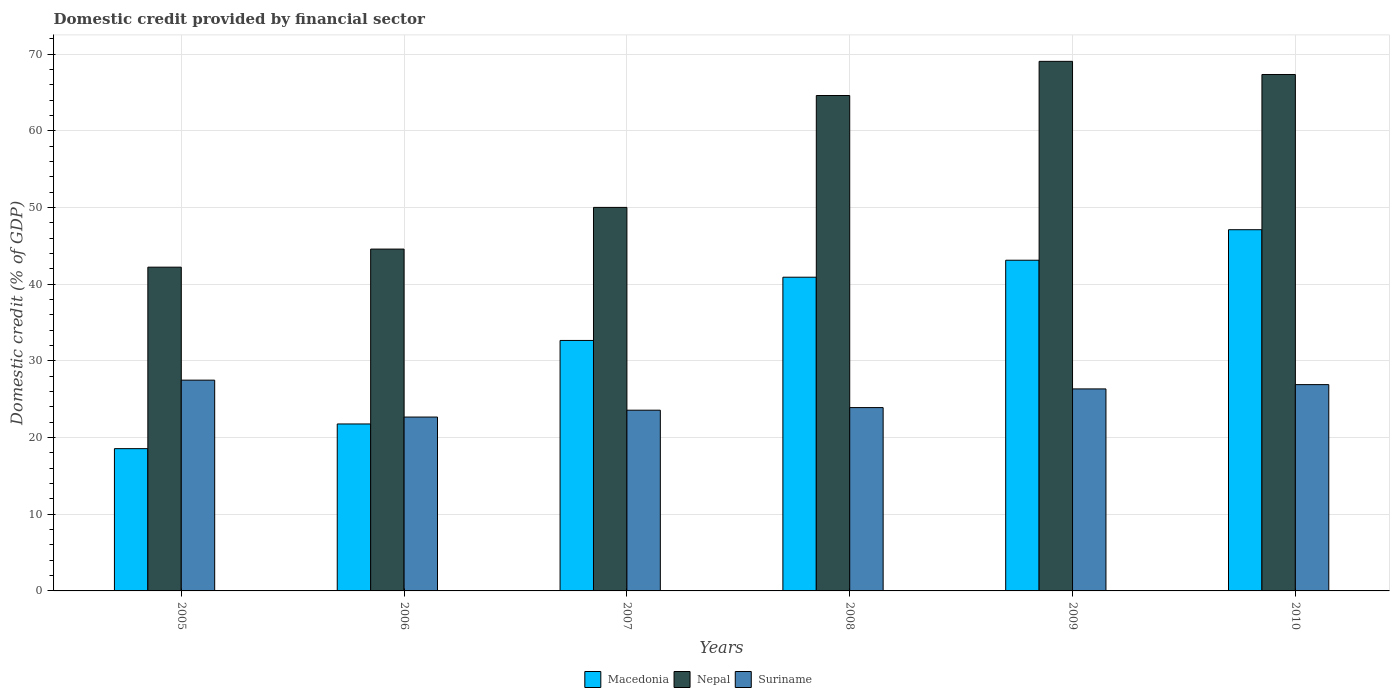How many groups of bars are there?
Offer a terse response. 6. How many bars are there on the 2nd tick from the left?
Make the answer very short. 3. What is the label of the 5th group of bars from the left?
Provide a short and direct response. 2009. In how many cases, is the number of bars for a given year not equal to the number of legend labels?
Give a very brief answer. 0. What is the domestic credit in Nepal in 2006?
Your answer should be very brief. 44.58. Across all years, what is the maximum domestic credit in Suriname?
Ensure brevity in your answer.  27.49. Across all years, what is the minimum domestic credit in Suriname?
Offer a terse response. 22.68. What is the total domestic credit in Macedonia in the graph?
Give a very brief answer. 204.15. What is the difference between the domestic credit in Nepal in 2007 and that in 2010?
Provide a short and direct response. -17.33. What is the difference between the domestic credit in Nepal in 2005 and the domestic credit in Suriname in 2009?
Offer a terse response. 15.88. What is the average domestic credit in Nepal per year?
Ensure brevity in your answer.  56.31. In the year 2009, what is the difference between the domestic credit in Nepal and domestic credit in Suriname?
Give a very brief answer. 42.72. In how many years, is the domestic credit in Suriname greater than 64 %?
Keep it short and to the point. 0. What is the ratio of the domestic credit in Suriname in 2005 to that in 2006?
Offer a terse response. 1.21. Is the domestic credit in Nepal in 2007 less than that in 2009?
Your answer should be very brief. Yes. Is the difference between the domestic credit in Nepal in 2006 and 2007 greater than the difference between the domestic credit in Suriname in 2006 and 2007?
Give a very brief answer. No. What is the difference between the highest and the second highest domestic credit in Macedonia?
Ensure brevity in your answer.  3.98. What is the difference between the highest and the lowest domestic credit in Macedonia?
Offer a terse response. 28.55. In how many years, is the domestic credit in Nepal greater than the average domestic credit in Nepal taken over all years?
Provide a short and direct response. 3. What does the 3rd bar from the left in 2009 represents?
Your response must be concise. Suriname. What does the 3rd bar from the right in 2008 represents?
Give a very brief answer. Macedonia. Is it the case that in every year, the sum of the domestic credit in Nepal and domestic credit in Macedonia is greater than the domestic credit in Suriname?
Your answer should be very brief. Yes. How many bars are there?
Offer a very short reply. 18. How many years are there in the graph?
Ensure brevity in your answer.  6. Are the values on the major ticks of Y-axis written in scientific E-notation?
Your answer should be compact. No. Does the graph contain grids?
Offer a terse response. Yes. Where does the legend appear in the graph?
Give a very brief answer. Bottom center. How many legend labels are there?
Provide a short and direct response. 3. What is the title of the graph?
Keep it short and to the point. Domestic credit provided by financial sector. Does "Venezuela" appear as one of the legend labels in the graph?
Ensure brevity in your answer.  No. What is the label or title of the X-axis?
Make the answer very short. Years. What is the label or title of the Y-axis?
Make the answer very short. Domestic credit (% of GDP). What is the Domestic credit (% of GDP) in Macedonia in 2005?
Your answer should be compact. 18.55. What is the Domestic credit (% of GDP) in Nepal in 2005?
Your answer should be very brief. 42.22. What is the Domestic credit (% of GDP) of Suriname in 2005?
Your response must be concise. 27.49. What is the Domestic credit (% of GDP) of Macedonia in 2006?
Your answer should be very brief. 21.78. What is the Domestic credit (% of GDP) in Nepal in 2006?
Offer a terse response. 44.58. What is the Domestic credit (% of GDP) in Suriname in 2006?
Offer a terse response. 22.68. What is the Domestic credit (% of GDP) of Macedonia in 2007?
Provide a short and direct response. 32.67. What is the Domestic credit (% of GDP) of Nepal in 2007?
Provide a short and direct response. 50.02. What is the Domestic credit (% of GDP) in Suriname in 2007?
Keep it short and to the point. 23.57. What is the Domestic credit (% of GDP) of Macedonia in 2008?
Your answer should be very brief. 40.91. What is the Domestic credit (% of GDP) of Nepal in 2008?
Provide a succinct answer. 64.61. What is the Domestic credit (% of GDP) of Suriname in 2008?
Your answer should be compact. 23.91. What is the Domestic credit (% of GDP) in Macedonia in 2009?
Your answer should be very brief. 43.13. What is the Domestic credit (% of GDP) in Nepal in 2009?
Ensure brevity in your answer.  69.07. What is the Domestic credit (% of GDP) of Suriname in 2009?
Provide a short and direct response. 26.35. What is the Domestic credit (% of GDP) of Macedonia in 2010?
Your response must be concise. 47.11. What is the Domestic credit (% of GDP) of Nepal in 2010?
Provide a succinct answer. 67.35. What is the Domestic credit (% of GDP) in Suriname in 2010?
Offer a terse response. 26.91. Across all years, what is the maximum Domestic credit (% of GDP) of Macedonia?
Make the answer very short. 47.11. Across all years, what is the maximum Domestic credit (% of GDP) of Nepal?
Make the answer very short. 69.07. Across all years, what is the maximum Domestic credit (% of GDP) of Suriname?
Offer a terse response. 27.49. Across all years, what is the minimum Domestic credit (% of GDP) in Macedonia?
Make the answer very short. 18.55. Across all years, what is the minimum Domestic credit (% of GDP) in Nepal?
Provide a succinct answer. 42.22. Across all years, what is the minimum Domestic credit (% of GDP) of Suriname?
Give a very brief answer. 22.68. What is the total Domestic credit (% of GDP) in Macedonia in the graph?
Your answer should be compact. 204.15. What is the total Domestic credit (% of GDP) in Nepal in the graph?
Your response must be concise. 337.86. What is the total Domestic credit (% of GDP) of Suriname in the graph?
Provide a short and direct response. 150.9. What is the difference between the Domestic credit (% of GDP) in Macedonia in 2005 and that in 2006?
Provide a short and direct response. -3.22. What is the difference between the Domestic credit (% of GDP) of Nepal in 2005 and that in 2006?
Your response must be concise. -2.36. What is the difference between the Domestic credit (% of GDP) in Suriname in 2005 and that in 2006?
Offer a terse response. 4.81. What is the difference between the Domestic credit (% of GDP) in Macedonia in 2005 and that in 2007?
Ensure brevity in your answer.  -14.11. What is the difference between the Domestic credit (% of GDP) in Nepal in 2005 and that in 2007?
Your answer should be compact. -7.8. What is the difference between the Domestic credit (% of GDP) of Suriname in 2005 and that in 2007?
Provide a short and direct response. 3.92. What is the difference between the Domestic credit (% of GDP) in Macedonia in 2005 and that in 2008?
Offer a very short reply. -22.36. What is the difference between the Domestic credit (% of GDP) of Nepal in 2005 and that in 2008?
Make the answer very short. -22.39. What is the difference between the Domestic credit (% of GDP) in Suriname in 2005 and that in 2008?
Offer a terse response. 3.58. What is the difference between the Domestic credit (% of GDP) in Macedonia in 2005 and that in 2009?
Provide a short and direct response. -24.57. What is the difference between the Domestic credit (% of GDP) of Nepal in 2005 and that in 2009?
Provide a succinct answer. -26.84. What is the difference between the Domestic credit (% of GDP) of Macedonia in 2005 and that in 2010?
Your response must be concise. -28.55. What is the difference between the Domestic credit (% of GDP) of Nepal in 2005 and that in 2010?
Your answer should be very brief. -25.13. What is the difference between the Domestic credit (% of GDP) in Suriname in 2005 and that in 2010?
Provide a succinct answer. 0.58. What is the difference between the Domestic credit (% of GDP) of Macedonia in 2006 and that in 2007?
Your answer should be compact. -10.89. What is the difference between the Domestic credit (% of GDP) of Nepal in 2006 and that in 2007?
Your answer should be very brief. -5.44. What is the difference between the Domestic credit (% of GDP) of Suriname in 2006 and that in 2007?
Make the answer very short. -0.89. What is the difference between the Domestic credit (% of GDP) in Macedonia in 2006 and that in 2008?
Ensure brevity in your answer.  -19.14. What is the difference between the Domestic credit (% of GDP) in Nepal in 2006 and that in 2008?
Your response must be concise. -20.03. What is the difference between the Domestic credit (% of GDP) of Suriname in 2006 and that in 2008?
Your response must be concise. -1.24. What is the difference between the Domestic credit (% of GDP) in Macedonia in 2006 and that in 2009?
Make the answer very short. -21.35. What is the difference between the Domestic credit (% of GDP) of Nepal in 2006 and that in 2009?
Keep it short and to the point. -24.48. What is the difference between the Domestic credit (% of GDP) of Suriname in 2006 and that in 2009?
Give a very brief answer. -3.67. What is the difference between the Domestic credit (% of GDP) of Macedonia in 2006 and that in 2010?
Provide a succinct answer. -25.33. What is the difference between the Domestic credit (% of GDP) of Nepal in 2006 and that in 2010?
Provide a short and direct response. -22.77. What is the difference between the Domestic credit (% of GDP) in Suriname in 2006 and that in 2010?
Provide a succinct answer. -4.23. What is the difference between the Domestic credit (% of GDP) of Macedonia in 2007 and that in 2008?
Provide a short and direct response. -8.25. What is the difference between the Domestic credit (% of GDP) in Nepal in 2007 and that in 2008?
Give a very brief answer. -14.59. What is the difference between the Domestic credit (% of GDP) in Suriname in 2007 and that in 2008?
Provide a short and direct response. -0.34. What is the difference between the Domestic credit (% of GDP) of Macedonia in 2007 and that in 2009?
Keep it short and to the point. -10.46. What is the difference between the Domestic credit (% of GDP) of Nepal in 2007 and that in 2009?
Offer a terse response. -19.05. What is the difference between the Domestic credit (% of GDP) of Suriname in 2007 and that in 2009?
Your answer should be very brief. -2.78. What is the difference between the Domestic credit (% of GDP) in Macedonia in 2007 and that in 2010?
Offer a terse response. -14.44. What is the difference between the Domestic credit (% of GDP) in Nepal in 2007 and that in 2010?
Give a very brief answer. -17.33. What is the difference between the Domestic credit (% of GDP) in Suriname in 2007 and that in 2010?
Offer a very short reply. -3.33. What is the difference between the Domestic credit (% of GDP) in Macedonia in 2008 and that in 2009?
Your answer should be compact. -2.22. What is the difference between the Domestic credit (% of GDP) of Nepal in 2008 and that in 2009?
Your answer should be very brief. -4.46. What is the difference between the Domestic credit (% of GDP) in Suriname in 2008 and that in 2009?
Provide a short and direct response. -2.44. What is the difference between the Domestic credit (% of GDP) in Macedonia in 2008 and that in 2010?
Ensure brevity in your answer.  -6.2. What is the difference between the Domestic credit (% of GDP) in Nepal in 2008 and that in 2010?
Ensure brevity in your answer.  -2.74. What is the difference between the Domestic credit (% of GDP) of Suriname in 2008 and that in 2010?
Ensure brevity in your answer.  -2.99. What is the difference between the Domestic credit (% of GDP) in Macedonia in 2009 and that in 2010?
Your answer should be very brief. -3.98. What is the difference between the Domestic credit (% of GDP) in Nepal in 2009 and that in 2010?
Your answer should be compact. 1.71. What is the difference between the Domestic credit (% of GDP) in Suriname in 2009 and that in 2010?
Offer a terse response. -0.56. What is the difference between the Domestic credit (% of GDP) in Macedonia in 2005 and the Domestic credit (% of GDP) in Nepal in 2006?
Make the answer very short. -26.03. What is the difference between the Domestic credit (% of GDP) in Macedonia in 2005 and the Domestic credit (% of GDP) in Suriname in 2006?
Provide a short and direct response. -4.12. What is the difference between the Domestic credit (% of GDP) of Nepal in 2005 and the Domestic credit (% of GDP) of Suriname in 2006?
Provide a succinct answer. 19.55. What is the difference between the Domestic credit (% of GDP) in Macedonia in 2005 and the Domestic credit (% of GDP) in Nepal in 2007?
Keep it short and to the point. -31.47. What is the difference between the Domestic credit (% of GDP) of Macedonia in 2005 and the Domestic credit (% of GDP) of Suriname in 2007?
Offer a very short reply. -5.02. What is the difference between the Domestic credit (% of GDP) in Nepal in 2005 and the Domestic credit (% of GDP) in Suriname in 2007?
Ensure brevity in your answer.  18.65. What is the difference between the Domestic credit (% of GDP) in Macedonia in 2005 and the Domestic credit (% of GDP) in Nepal in 2008?
Make the answer very short. -46.06. What is the difference between the Domestic credit (% of GDP) in Macedonia in 2005 and the Domestic credit (% of GDP) in Suriname in 2008?
Your answer should be very brief. -5.36. What is the difference between the Domestic credit (% of GDP) in Nepal in 2005 and the Domestic credit (% of GDP) in Suriname in 2008?
Keep it short and to the point. 18.31. What is the difference between the Domestic credit (% of GDP) in Macedonia in 2005 and the Domestic credit (% of GDP) in Nepal in 2009?
Your answer should be very brief. -50.51. What is the difference between the Domestic credit (% of GDP) of Macedonia in 2005 and the Domestic credit (% of GDP) of Suriname in 2009?
Provide a short and direct response. -7.79. What is the difference between the Domestic credit (% of GDP) of Nepal in 2005 and the Domestic credit (% of GDP) of Suriname in 2009?
Your response must be concise. 15.88. What is the difference between the Domestic credit (% of GDP) of Macedonia in 2005 and the Domestic credit (% of GDP) of Nepal in 2010?
Your response must be concise. -48.8. What is the difference between the Domestic credit (% of GDP) in Macedonia in 2005 and the Domestic credit (% of GDP) in Suriname in 2010?
Make the answer very short. -8.35. What is the difference between the Domestic credit (% of GDP) in Nepal in 2005 and the Domestic credit (% of GDP) in Suriname in 2010?
Your answer should be very brief. 15.32. What is the difference between the Domestic credit (% of GDP) of Macedonia in 2006 and the Domestic credit (% of GDP) of Nepal in 2007?
Your answer should be compact. -28.25. What is the difference between the Domestic credit (% of GDP) of Macedonia in 2006 and the Domestic credit (% of GDP) of Suriname in 2007?
Provide a short and direct response. -1.8. What is the difference between the Domestic credit (% of GDP) of Nepal in 2006 and the Domestic credit (% of GDP) of Suriname in 2007?
Your response must be concise. 21.01. What is the difference between the Domestic credit (% of GDP) in Macedonia in 2006 and the Domestic credit (% of GDP) in Nepal in 2008?
Offer a terse response. -42.84. What is the difference between the Domestic credit (% of GDP) of Macedonia in 2006 and the Domestic credit (% of GDP) of Suriname in 2008?
Offer a very short reply. -2.14. What is the difference between the Domestic credit (% of GDP) of Nepal in 2006 and the Domestic credit (% of GDP) of Suriname in 2008?
Provide a succinct answer. 20.67. What is the difference between the Domestic credit (% of GDP) in Macedonia in 2006 and the Domestic credit (% of GDP) in Nepal in 2009?
Offer a very short reply. -47.29. What is the difference between the Domestic credit (% of GDP) of Macedonia in 2006 and the Domestic credit (% of GDP) of Suriname in 2009?
Provide a short and direct response. -4.57. What is the difference between the Domestic credit (% of GDP) of Nepal in 2006 and the Domestic credit (% of GDP) of Suriname in 2009?
Ensure brevity in your answer.  18.24. What is the difference between the Domestic credit (% of GDP) of Macedonia in 2006 and the Domestic credit (% of GDP) of Nepal in 2010?
Ensure brevity in your answer.  -45.58. What is the difference between the Domestic credit (% of GDP) of Macedonia in 2006 and the Domestic credit (% of GDP) of Suriname in 2010?
Ensure brevity in your answer.  -5.13. What is the difference between the Domestic credit (% of GDP) of Nepal in 2006 and the Domestic credit (% of GDP) of Suriname in 2010?
Provide a short and direct response. 17.68. What is the difference between the Domestic credit (% of GDP) of Macedonia in 2007 and the Domestic credit (% of GDP) of Nepal in 2008?
Offer a very short reply. -31.95. What is the difference between the Domestic credit (% of GDP) in Macedonia in 2007 and the Domestic credit (% of GDP) in Suriname in 2008?
Provide a succinct answer. 8.76. What is the difference between the Domestic credit (% of GDP) in Nepal in 2007 and the Domestic credit (% of GDP) in Suriname in 2008?
Give a very brief answer. 26.11. What is the difference between the Domestic credit (% of GDP) of Macedonia in 2007 and the Domestic credit (% of GDP) of Nepal in 2009?
Offer a very short reply. -36.4. What is the difference between the Domestic credit (% of GDP) of Macedonia in 2007 and the Domestic credit (% of GDP) of Suriname in 2009?
Give a very brief answer. 6.32. What is the difference between the Domestic credit (% of GDP) in Nepal in 2007 and the Domestic credit (% of GDP) in Suriname in 2009?
Offer a terse response. 23.67. What is the difference between the Domestic credit (% of GDP) in Macedonia in 2007 and the Domestic credit (% of GDP) in Nepal in 2010?
Make the answer very short. -34.69. What is the difference between the Domestic credit (% of GDP) in Macedonia in 2007 and the Domestic credit (% of GDP) in Suriname in 2010?
Your response must be concise. 5.76. What is the difference between the Domestic credit (% of GDP) of Nepal in 2007 and the Domestic credit (% of GDP) of Suriname in 2010?
Offer a very short reply. 23.11. What is the difference between the Domestic credit (% of GDP) of Macedonia in 2008 and the Domestic credit (% of GDP) of Nepal in 2009?
Your response must be concise. -28.15. What is the difference between the Domestic credit (% of GDP) of Macedonia in 2008 and the Domestic credit (% of GDP) of Suriname in 2009?
Provide a succinct answer. 14.57. What is the difference between the Domestic credit (% of GDP) of Nepal in 2008 and the Domestic credit (% of GDP) of Suriname in 2009?
Provide a succinct answer. 38.27. What is the difference between the Domestic credit (% of GDP) of Macedonia in 2008 and the Domestic credit (% of GDP) of Nepal in 2010?
Your answer should be very brief. -26.44. What is the difference between the Domestic credit (% of GDP) in Macedonia in 2008 and the Domestic credit (% of GDP) in Suriname in 2010?
Your answer should be very brief. 14.01. What is the difference between the Domestic credit (% of GDP) of Nepal in 2008 and the Domestic credit (% of GDP) of Suriname in 2010?
Provide a short and direct response. 37.71. What is the difference between the Domestic credit (% of GDP) of Macedonia in 2009 and the Domestic credit (% of GDP) of Nepal in 2010?
Provide a short and direct response. -24.23. What is the difference between the Domestic credit (% of GDP) in Macedonia in 2009 and the Domestic credit (% of GDP) in Suriname in 2010?
Ensure brevity in your answer.  16.22. What is the difference between the Domestic credit (% of GDP) in Nepal in 2009 and the Domestic credit (% of GDP) in Suriname in 2010?
Your response must be concise. 42.16. What is the average Domestic credit (% of GDP) in Macedonia per year?
Provide a succinct answer. 34.03. What is the average Domestic credit (% of GDP) of Nepal per year?
Your answer should be very brief. 56.31. What is the average Domestic credit (% of GDP) in Suriname per year?
Keep it short and to the point. 25.15. In the year 2005, what is the difference between the Domestic credit (% of GDP) in Macedonia and Domestic credit (% of GDP) in Nepal?
Keep it short and to the point. -23.67. In the year 2005, what is the difference between the Domestic credit (% of GDP) of Macedonia and Domestic credit (% of GDP) of Suriname?
Keep it short and to the point. -8.94. In the year 2005, what is the difference between the Domestic credit (% of GDP) in Nepal and Domestic credit (% of GDP) in Suriname?
Your answer should be compact. 14.73. In the year 2006, what is the difference between the Domestic credit (% of GDP) of Macedonia and Domestic credit (% of GDP) of Nepal?
Give a very brief answer. -22.81. In the year 2006, what is the difference between the Domestic credit (% of GDP) in Macedonia and Domestic credit (% of GDP) in Suriname?
Ensure brevity in your answer.  -0.9. In the year 2006, what is the difference between the Domestic credit (% of GDP) of Nepal and Domestic credit (% of GDP) of Suriname?
Provide a short and direct response. 21.91. In the year 2007, what is the difference between the Domestic credit (% of GDP) of Macedonia and Domestic credit (% of GDP) of Nepal?
Give a very brief answer. -17.35. In the year 2007, what is the difference between the Domestic credit (% of GDP) of Macedonia and Domestic credit (% of GDP) of Suriname?
Your answer should be very brief. 9.1. In the year 2007, what is the difference between the Domestic credit (% of GDP) of Nepal and Domestic credit (% of GDP) of Suriname?
Ensure brevity in your answer.  26.45. In the year 2008, what is the difference between the Domestic credit (% of GDP) in Macedonia and Domestic credit (% of GDP) in Nepal?
Your answer should be very brief. -23.7. In the year 2008, what is the difference between the Domestic credit (% of GDP) in Macedonia and Domestic credit (% of GDP) in Suriname?
Ensure brevity in your answer.  17. In the year 2008, what is the difference between the Domestic credit (% of GDP) in Nepal and Domestic credit (% of GDP) in Suriname?
Keep it short and to the point. 40.7. In the year 2009, what is the difference between the Domestic credit (% of GDP) in Macedonia and Domestic credit (% of GDP) in Nepal?
Offer a terse response. -25.94. In the year 2009, what is the difference between the Domestic credit (% of GDP) in Macedonia and Domestic credit (% of GDP) in Suriname?
Ensure brevity in your answer.  16.78. In the year 2009, what is the difference between the Domestic credit (% of GDP) of Nepal and Domestic credit (% of GDP) of Suriname?
Make the answer very short. 42.72. In the year 2010, what is the difference between the Domestic credit (% of GDP) in Macedonia and Domestic credit (% of GDP) in Nepal?
Ensure brevity in your answer.  -20.25. In the year 2010, what is the difference between the Domestic credit (% of GDP) in Macedonia and Domestic credit (% of GDP) in Suriname?
Your response must be concise. 20.2. In the year 2010, what is the difference between the Domestic credit (% of GDP) in Nepal and Domestic credit (% of GDP) in Suriname?
Your answer should be compact. 40.45. What is the ratio of the Domestic credit (% of GDP) in Macedonia in 2005 to that in 2006?
Your response must be concise. 0.85. What is the ratio of the Domestic credit (% of GDP) in Nepal in 2005 to that in 2006?
Keep it short and to the point. 0.95. What is the ratio of the Domestic credit (% of GDP) in Suriname in 2005 to that in 2006?
Your answer should be compact. 1.21. What is the ratio of the Domestic credit (% of GDP) of Macedonia in 2005 to that in 2007?
Provide a short and direct response. 0.57. What is the ratio of the Domestic credit (% of GDP) of Nepal in 2005 to that in 2007?
Ensure brevity in your answer.  0.84. What is the ratio of the Domestic credit (% of GDP) of Suriname in 2005 to that in 2007?
Ensure brevity in your answer.  1.17. What is the ratio of the Domestic credit (% of GDP) of Macedonia in 2005 to that in 2008?
Your answer should be compact. 0.45. What is the ratio of the Domestic credit (% of GDP) of Nepal in 2005 to that in 2008?
Keep it short and to the point. 0.65. What is the ratio of the Domestic credit (% of GDP) in Suriname in 2005 to that in 2008?
Your answer should be very brief. 1.15. What is the ratio of the Domestic credit (% of GDP) of Macedonia in 2005 to that in 2009?
Offer a terse response. 0.43. What is the ratio of the Domestic credit (% of GDP) of Nepal in 2005 to that in 2009?
Offer a very short reply. 0.61. What is the ratio of the Domestic credit (% of GDP) in Suriname in 2005 to that in 2009?
Your answer should be very brief. 1.04. What is the ratio of the Domestic credit (% of GDP) of Macedonia in 2005 to that in 2010?
Ensure brevity in your answer.  0.39. What is the ratio of the Domestic credit (% of GDP) of Nepal in 2005 to that in 2010?
Offer a terse response. 0.63. What is the ratio of the Domestic credit (% of GDP) of Suriname in 2005 to that in 2010?
Ensure brevity in your answer.  1.02. What is the ratio of the Domestic credit (% of GDP) in Macedonia in 2006 to that in 2007?
Provide a succinct answer. 0.67. What is the ratio of the Domestic credit (% of GDP) of Nepal in 2006 to that in 2007?
Your answer should be compact. 0.89. What is the ratio of the Domestic credit (% of GDP) of Macedonia in 2006 to that in 2008?
Keep it short and to the point. 0.53. What is the ratio of the Domestic credit (% of GDP) of Nepal in 2006 to that in 2008?
Your response must be concise. 0.69. What is the ratio of the Domestic credit (% of GDP) of Suriname in 2006 to that in 2008?
Keep it short and to the point. 0.95. What is the ratio of the Domestic credit (% of GDP) of Macedonia in 2006 to that in 2009?
Keep it short and to the point. 0.5. What is the ratio of the Domestic credit (% of GDP) in Nepal in 2006 to that in 2009?
Ensure brevity in your answer.  0.65. What is the ratio of the Domestic credit (% of GDP) in Suriname in 2006 to that in 2009?
Keep it short and to the point. 0.86. What is the ratio of the Domestic credit (% of GDP) of Macedonia in 2006 to that in 2010?
Make the answer very short. 0.46. What is the ratio of the Domestic credit (% of GDP) in Nepal in 2006 to that in 2010?
Keep it short and to the point. 0.66. What is the ratio of the Domestic credit (% of GDP) of Suriname in 2006 to that in 2010?
Your answer should be compact. 0.84. What is the ratio of the Domestic credit (% of GDP) in Macedonia in 2007 to that in 2008?
Make the answer very short. 0.8. What is the ratio of the Domestic credit (% of GDP) in Nepal in 2007 to that in 2008?
Make the answer very short. 0.77. What is the ratio of the Domestic credit (% of GDP) in Suriname in 2007 to that in 2008?
Your answer should be very brief. 0.99. What is the ratio of the Domestic credit (% of GDP) of Macedonia in 2007 to that in 2009?
Provide a succinct answer. 0.76. What is the ratio of the Domestic credit (% of GDP) of Nepal in 2007 to that in 2009?
Your answer should be very brief. 0.72. What is the ratio of the Domestic credit (% of GDP) of Suriname in 2007 to that in 2009?
Give a very brief answer. 0.89. What is the ratio of the Domestic credit (% of GDP) of Macedonia in 2007 to that in 2010?
Your response must be concise. 0.69. What is the ratio of the Domestic credit (% of GDP) in Nepal in 2007 to that in 2010?
Make the answer very short. 0.74. What is the ratio of the Domestic credit (% of GDP) in Suriname in 2007 to that in 2010?
Ensure brevity in your answer.  0.88. What is the ratio of the Domestic credit (% of GDP) in Macedonia in 2008 to that in 2009?
Provide a succinct answer. 0.95. What is the ratio of the Domestic credit (% of GDP) of Nepal in 2008 to that in 2009?
Your response must be concise. 0.94. What is the ratio of the Domestic credit (% of GDP) of Suriname in 2008 to that in 2009?
Give a very brief answer. 0.91. What is the ratio of the Domestic credit (% of GDP) of Macedonia in 2008 to that in 2010?
Offer a very short reply. 0.87. What is the ratio of the Domestic credit (% of GDP) in Nepal in 2008 to that in 2010?
Your response must be concise. 0.96. What is the ratio of the Domestic credit (% of GDP) in Suriname in 2008 to that in 2010?
Your response must be concise. 0.89. What is the ratio of the Domestic credit (% of GDP) of Macedonia in 2009 to that in 2010?
Give a very brief answer. 0.92. What is the ratio of the Domestic credit (% of GDP) of Nepal in 2009 to that in 2010?
Offer a very short reply. 1.03. What is the ratio of the Domestic credit (% of GDP) in Suriname in 2009 to that in 2010?
Your answer should be very brief. 0.98. What is the difference between the highest and the second highest Domestic credit (% of GDP) in Macedonia?
Keep it short and to the point. 3.98. What is the difference between the highest and the second highest Domestic credit (% of GDP) of Nepal?
Give a very brief answer. 1.71. What is the difference between the highest and the second highest Domestic credit (% of GDP) of Suriname?
Ensure brevity in your answer.  0.58. What is the difference between the highest and the lowest Domestic credit (% of GDP) in Macedonia?
Your answer should be very brief. 28.55. What is the difference between the highest and the lowest Domestic credit (% of GDP) of Nepal?
Your answer should be very brief. 26.84. What is the difference between the highest and the lowest Domestic credit (% of GDP) in Suriname?
Ensure brevity in your answer.  4.81. 